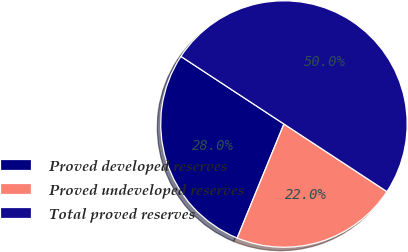Convert chart. <chart><loc_0><loc_0><loc_500><loc_500><pie_chart><fcel>Proved developed reserves<fcel>Proved undeveloped reserves<fcel>Total proved reserves<nl><fcel>28.05%<fcel>21.95%<fcel>50.0%<nl></chart> 